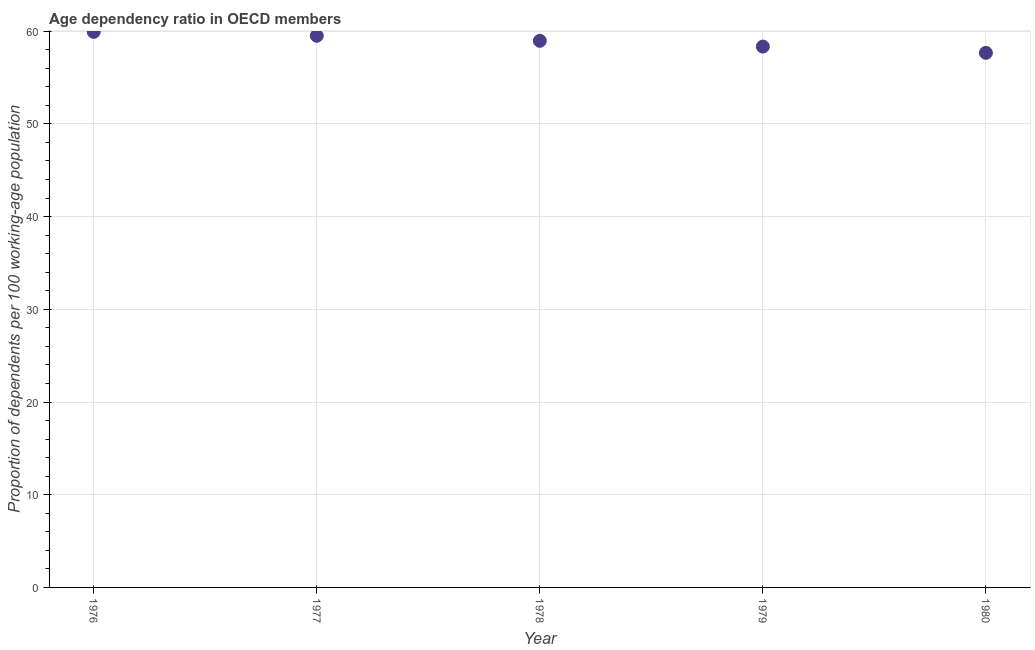What is the age dependency ratio in 1980?
Your answer should be very brief. 57.67. Across all years, what is the maximum age dependency ratio?
Your answer should be very brief. 59.93. Across all years, what is the minimum age dependency ratio?
Provide a short and direct response. 57.67. In which year was the age dependency ratio maximum?
Provide a short and direct response. 1976. In which year was the age dependency ratio minimum?
Make the answer very short. 1980. What is the sum of the age dependency ratio?
Keep it short and to the point. 294.4. What is the difference between the age dependency ratio in 1977 and 1978?
Keep it short and to the point. 0.54. What is the average age dependency ratio per year?
Provide a short and direct response. 58.88. What is the median age dependency ratio?
Offer a very short reply. 58.96. In how many years, is the age dependency ratio greater than 40 ?
Provide a succinct answer. 5. What is the ratio of the age dependency ratio in 1979 to that in 1980?
Provide a short and direct response. 1.01. Is the difference between the age dependency ratio in 1976 and 1980 greater than the difference between any two years?
Your answer should be compact. Yes. What is the difference between the highest and the second highest age dependency ratio?
Offer a terse response. 0.42. Is the sum of the age dependency ratio in 1979 and 1980 greater than the maximum age dependency ratio across all years?
Your answer should be compact. Yes. What is the difference between the highest and the lowest age dependency ratio?
Provide a succinct answer. 2.26. Does the age dependency ratio monotonically increase over the years?
Provide a short and direct response. No. How many years are there in the graph?
Make the answer very short. 5. What is the difference between two consecutive major ticks on the Y-axis?
Give a very brief answer. 10. Are the values on the major ticks of Y-axis written in scientific E-notation?
Offer a terse response. No. Does the graph contain any zero values?
Your response must be concise. No. Does the graph contain grids?
Provide a succinct answer. Yes. What is the title of the graph?
Give a very brief answer. Age dependency ratio in OECD members. What is the label or title of the Y-axis?
Offer a terse response. Proportion of dependents per 100 working-age population. What is the Proportion of dependents per 100 working-age population in 1976?
Keep it short and to the point. 59.93. What is the Proportion of dependents per 100 working-age population in 1977?
Keep it short and to the point. 59.5. What is the Proportion of dependents per 100 working-age population in 1978?
Make the answer very short. 58.96. What is the Proportion of dependents per 100 working-age population in 1979?
Keep it short and to the point. 58.34. What is the Proportion of dependents per 100 working-age population in 1980?
Provide a short and direct response. 57.67. What is the difference between the Proportion of dependents per 100 working-age population in 1976 and 1977?
Your answer should be very brief. 0.42. What is the difference between the Proportion of dependents per 100 working-age population in 1976 and 1978?
Keep it short and to the point. 0.96. What is the difference between the Proportion of dependents per 100 working-age population in 1976 and 1979?
Give a very brief answer. 1.59. What is the difference between the Proportion of dependents per 100 working-age population in 1976 and 1980?
Offer a terse response. 2.26. What is the difference between the Proportion of dependents per 100 working-age population in 1977 and 1978?
Offer a very short reply. 0.54. What is the difference between the Proportion of dependents per 100 working-age population in 1977 and 1979?
Your response must be concise. 1.16. What is the difference between the Proportion of dependents per 100 working-age population in 1977 and 1980?
Offer a terse response. 1.84. What is the difference between the Proportion of dependents per 100 working-age population in 1978 and 1979?
Your answer should be compact. 0.62. What is the difference between the Proportion of dependents per 100 working-age population in 1978 and 1980?
Your answer should be compact. 1.3. What is the difference between the Proportion of dependents per 100 working-age population in 1979 and 1980?
Provide a succinct answer. 0.68. What is the ratio of the Proportion of dependents per 100 working-age population in 1976 to that in 1979?
Provide a short and direct response. 1.03. What is the ratio of the Proportion of dependents per 100 working-age population in 1976 to that in 1980?
Offer a very short reply. 1.04. What is the ratio of the Proportion of dependents per 100 working-age population in 1977 to that in 1978?
Provide a short and direct response. 1.01. What is the ratio of the Proportion of dependents per 100 working-age population in 1977 to that in 1979?
Provide a succinct answer. 1.02. What is the ratio of the Proportion of dependents per 100 working-age population in 1977 to that in 1980?
Offer a very short reply. 1.03. What is the ratio of the Proportion of dependents per 100 working-age population in 1978 to that in 1979?
Make the answer very short. 1.01. What is the ratio of the Proportion of dependents per 100 working-age population in 1978 to that in 1980?
Provide a succinct answer. 1.02. 